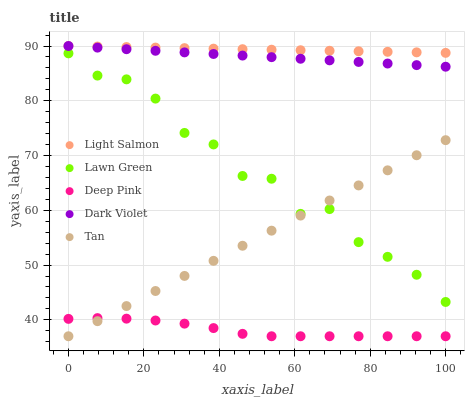Does Deep Pink have the minimum area under the curve?
Answer yes or no. Yes. Does Light Salmon have the maximum area under the curve?
Answer yes or no. Yes. Does Light Salmon have the minimum area under the curve?
Answer yes or no. No. Does Deep Pink have the maximum area under the curve?
Answer yes or no. No. Is Light Salmon the smoothest?
Answer yes or no. Yes. Is Lawn Green the roughest?
Answer yes or no. Yes. Is Deep Pink the smoothest?
Answer yes or no. No. Is Deep Pink the roughest?
Answer yes or no. No. Does Deep Pink have the lowest value?
Answer yes or no. Yes. Does Light Salmon have the lowest value?
Answer yes or no. No. Does Dark Violet have the highest value?
Answer yes or no. Yes. Does Deep Pink have the highest value?
Answer yes or no. No. Is Lawn Green less than Light Salmon?
Answer yes or no. Yes. Is Lawn Green greater than Deep Pink?
Answer yes or no. Yes. Does Light Salmon intersect Dark Violet?
Answer yes or no. Yes. Is Light Salmon less than Dark Violet?
Answer yes or no. No. Is Light Salmon greater than Dark Violet?
Answer yes or no. No. Does Lawn Green intersect Light Salmon?
Answer yes or no. No. 